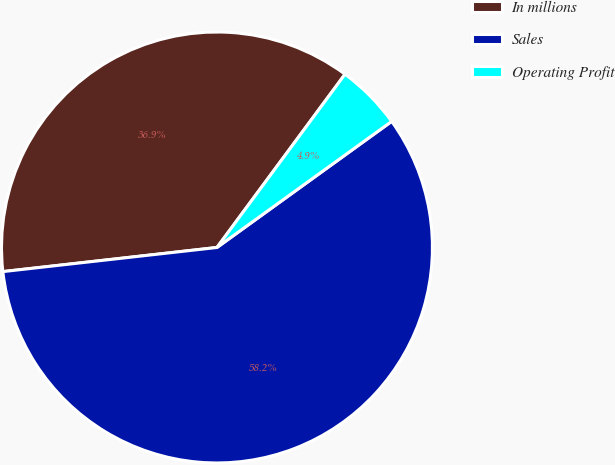Convert chart. <chart><loc_0><loc_0><loc_500><loc_500><pie_chart><fcel>In millions<fcel>Sales<fcel>Operating Profit<nl><fcel>36.92%<fcel>58.17%<fcel>4.92%<nl></chart> 